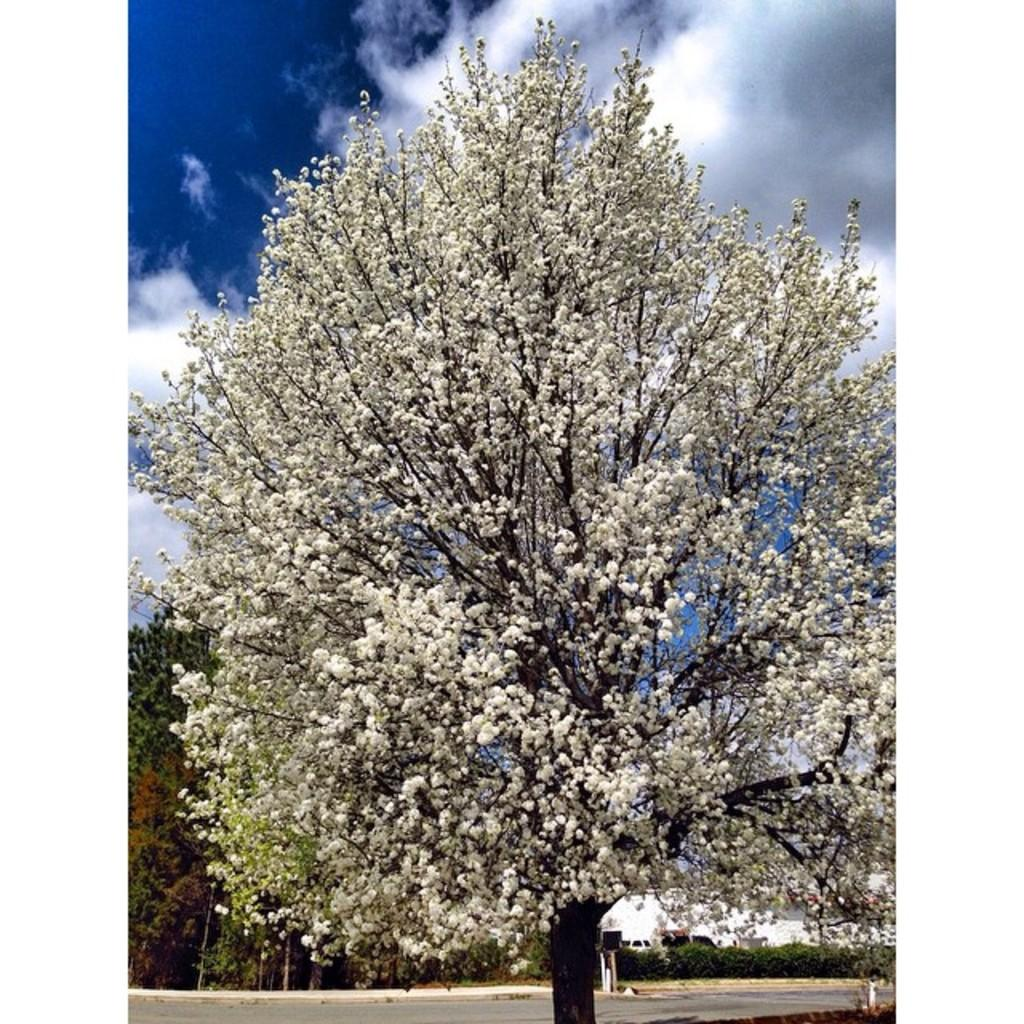What is located in the foreground of the image? There is a tree in the foreground of the image. What can be seen in the background of the image? In the background of the image, there is a road, shrubs, at least one building, trees, and the sky. Can you describe the sky in the image? The sky is visible in the background of the image, and clouds are present in the sky. What type of lamp can be seen hanging from the tree in the image? There is no lamp present in the image; it features a tree in the foreground and various elements in the background. 